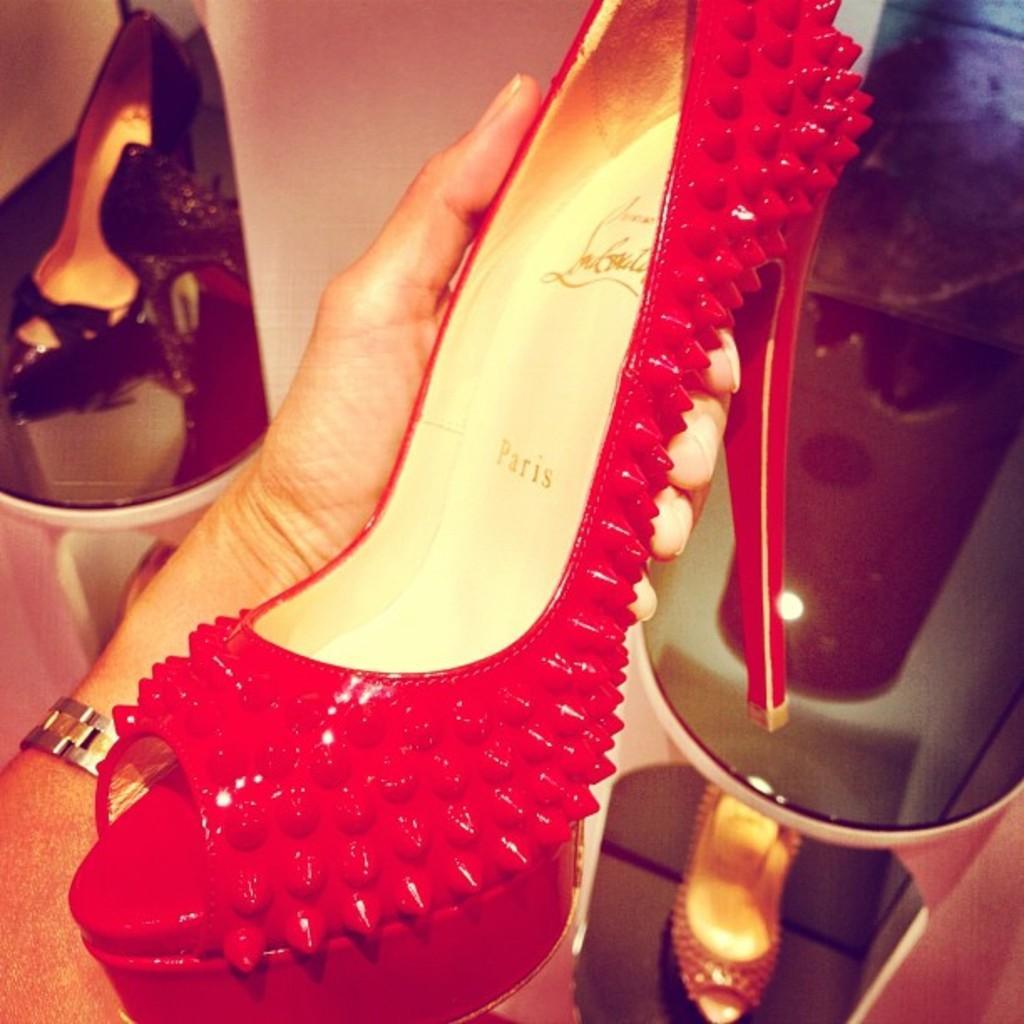In one or two sentences, can you explain what this image depicts? In this picture we can see a person hand is holding a sandal and in the background we can see sandals in racks. 